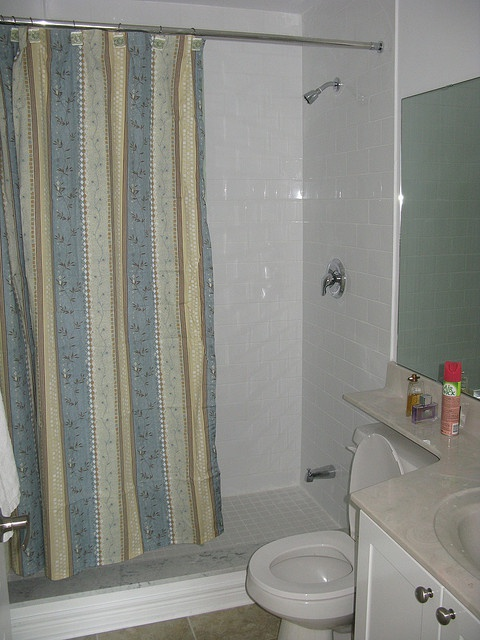Describe the objects in this image and their specific colors. I can see sink in gray tones, toilet in gray and darkgray tones, and bottle in gray, brown, and olive tones in this image. 